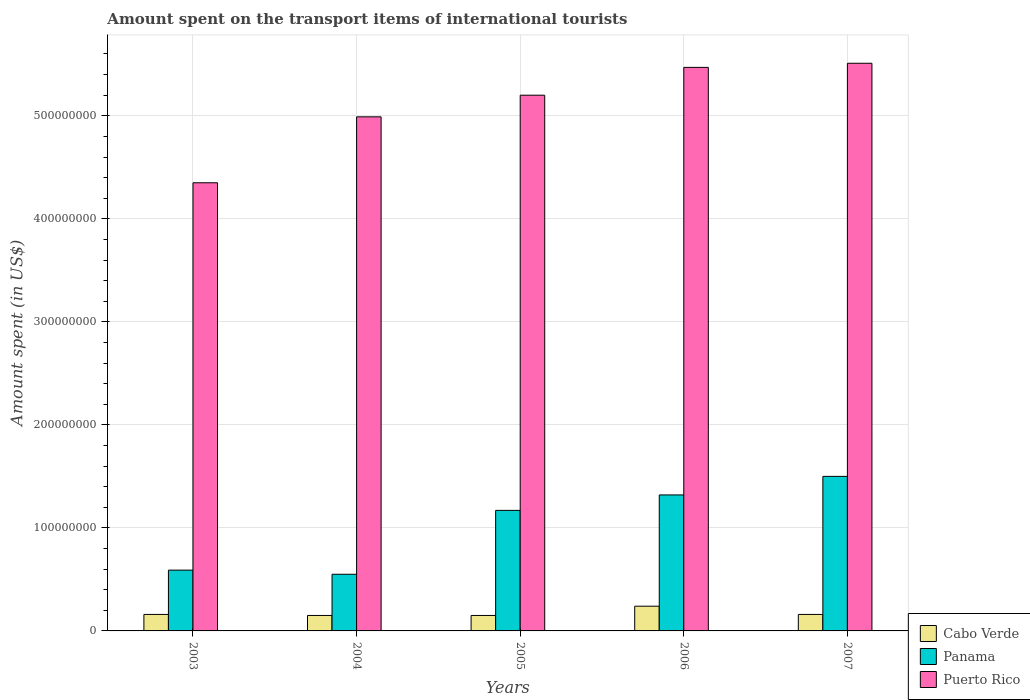How many groups of bars are there?
Give a very brief answer. 5. Are the number of bars on each tick of the X-axis equal?
Your answer should be very brief. Yes. What is the label of the 4th group of bars from the left?
Your answer should be compact. 2006. What is the amount spent on the transport items of international tourists in Panama in 2005?
Your answer should be compact. 1.17e+08. Across all years, what is the maximum amount spent on the transport items of international tourists in Panama?
Offer a terse response. 1.50e+08. Across all years, what is the minimum amount spent on the transport items of international tourists in Cabo Verde?
Offer a terse response. 1.50e+07. In which year was the amount spent on the transport items of international tourists in Cabo Verde maximum?
Make the answer very short. 2006. What is the total amount spent on the transport items of international tourists in Panama in the graph?
Offer a very short reply. 5.13e+08. What is the difference between the amount spent on the transport items of international tourists in Cabo Verde in 2005 and that in 2007?
Your response must be concise. -1.00e+06. What is the difference between the amount spent on the transport items of international tourists in Cabo Verde in 2006 and the amount spent on the transport items of international tourists in Puerto Rico in 2004?
Provide a short and direct response. -4.75e+08. What is the average amount spent on the transport items of international tourists in Puerto Rico per year?
Offer a terse response. 5.10e+08. In the year 2007, what is the difference between the amount spent on the transport items of international tourists in Cabo Verde and amount spent on the transport items of international tourists in Panama?
Your answer should be very brief. -1.34e+08. What is the ratio of the amount spent on the transport items of international tourists in Cabo Verde in 2003 to that in 2006?
Ensure brevity in your answer.  0.67. Is the amount spent on the transport items of international tourists in Panama in 2003 less than that in 2006?
Your response must be concise. Yes. Is the difference between the amount spent on the transport items of international tourists in Cabo Verde in 2005 and 2007 greater than the difference between the amount spent on the transport items of international tourists in Panama in 2005 and 2007?
Give a very brief answer. Yes. What is the difference between the highest and the second highest amount spent on the transport items of international tourists in Panama?
Keep it short and to the point. 1.80e+07. What is the difference between the highest and the lowest amount spent on the transport items of international tourists in Panama?
Provide a succinct answer. 9.50e+07. Is the sum of the amount spent on the transport items of international tourists in Cabo Verde in 2004 and 2005 greater than the maximum amount spent on the transport items of international tourists in Panama across all years?
Your answer should be compact. No. What does the 2nd bar from the left in 2004 represents?
Your answer should be compact. Panama. What does the 2nd bar from the right in 2006 represents?
Give a very brief answer. Panama. Is it the case that in every year, the sum of the amount spent on the transport items of international tourists in Puerto Rico and amount spent on the transport items of international tourists in Cabo Verde is greater than the amount spent on the transport items of international tourists in Panama?
Offer a terse response. Yes. How many years are there in the graph?
Offer a terse response. 5. What is the difference between two consecutive major ticks on the Y-axis?
Ensure brevity in your answer.  1.00e+08. Are the values on the major ticks of Y-axis written in scientific E-notation?
Your answer should be compact. No. Does the graph contain grids?
Ensure brevity in your answer.  Yes. How many legend labels are there?
Provide a short and direct response. 3. How are the legend labels stacked?
Your response must be concise. Vertical. What is the title of the graph?
Your answer should be compact. Amount spent on the transport items of international tourists. Does "Comoros" appear as one of the legend labels in the graph?
Provide a succinct answer. No. What is the label or title of the X-axis?
Offer a very short reply. Years. What is the label or title of the Y-axis?
Make the answer very short. Amount spent (in US$). What is the Amount spent (in US$) of Cabo Verde in 2003?
Give a very brief answer. 1.60e+07. What is the Amount spent (in US$) in Panama in 2003?
Your response must be concise. 5.90e+07. What is the Amount spent (in US$) of Puerto Rico in 2003?
Your answer should be compact. 4.35e+08. What is the Amount spent (in US$) of Cabo Verde in 2004?
Make the answer very short. 1.50e+07. What is the Amount spent (in US$) in Panama in 2004?
Your response must be concise. 5.50e+07. What is the Amount spent (in US$) of Puerto Rico in 2004?
Keep it short and to the point. 4.99e+08. What is the Amount spent (in US$) of Cabo Verde in 2005?
Your response must be concise. 1.50e+07. What is the Amount spent (in US$) in Panama in 2005?
Make the answer very short. 1.17e+08. What is the Amount spent (in US$) of Puerto Rico in 2005?
Your response must be concise. 5.20e+08. What is the Amount spent (in US$) in Cabo Verde in 2006?
Provide a short and direct response. 2.40e+07. What is the Amount spent (in US$) of Panama in 2006?
Your answer should be compact. 1.32e+08. What is the Amount spent (in US$) of Puerto Rico in 2006?
Ensure brevity in your answer.  5.47e+08. What is the Amount spent (in US$) of Cabo Verde in 2007?
Keep it short and to the point. 1.60e+07. What is the Amount spent (in US$) in Panama in 2007?
Your response must be concise. 1.50e+08. What is the Amount spent (in US$) in Puerto Rico in 2007?
Ensure brevity in your answer.  5.51e+08. Across all years, what is the maximum Amount spent (in US$) of Cabo Verde?
Your response must be concise. 2.40e+07. Across all years, what is the maximum Amount spent (in US$) in Panama?
Offer a very short reply. 1.50e+08. Across all years, what is the maximum Amount spent (in US$) in Puerto Rico?
Keep it short and to the point. 5.51e+08. Across all years, what is the minimum Amount spent (in US$) of Cabo Verde?
Provide a short and direct response. 1.50e+07. Across all years, what is the minimum Amount spent (in US$) of Panama?
Offer a very short reply. 5.50e+07. Across all years, what is the minimum Amount spent (in US$) in Puerto Rico?
Ensure brevity in your answer.  4.35e+08. What is the total Amount spent (in US$) in Cabo Verde in the graph?
Ensure brevity in your answer.  8.60e+07. What is the total Amount spent (in US$) of Panama in the graph?
Your answer should be compact. 5.13e+08. What is the total Amount spent (in US$) of Puerto Rico in the graph?
Provide a succinct answer. 2.55e+09. What is the difference between the Amount spent (in US$) of Cabo Verde in 2003 and that in 2004?
Provide a succinct answer. 1.00e+06. What is the difference between the Amount spent (in US$) in Panama in 2003 and that in 2004?
Your answer should be very brief. 4.00e+06. What is the difference between the Amount spent (in US$) in Puerto Rico in 2003 and that in 2004?
Provide a succinct answer. -6.40e+07. What is the difference between the Amount spent (in US$) in Panama in 2003 and that in 2005?
Provide a succinct answer. -5.80e+07. What is the difference between the Amount spent (in US$) in Puerto Rico in 2003 and that in 2005?
Offer a terse response. -8.50e+07. What is the difference between the Amount spent (in US$) in Cabo Verde in 2003 and that in 2006?
Your answer should be very brief. -8.00e+06. What is the difference between the Amount spent (in US$) in Panama in 2003 and that in 2006?
Give a very brief answer. -7.30e+07. What is the difference between the Amount spent (in US$) of Puerto Rico in 2003 and that in 2006?
Offer a terse response. -1.12e+08. What is the difference between the Amount spent (in US$) of Panama in 2003 and that in 2007?
Your answer should be compact. -9.10e+07. What is the difference between the Amount spent (in US$) of Puerto Rico in 2003 and that in 2007?
Your answer should be compact. -1.16e+08. What is the difference between the Amount spent (in US$) in Panama in 2004 and that in 2005?
Offer a terse response. -6.20e+07. What is the difference between the Amount spent (in US$) in Puerto Rico in 2004 and that in 2005?
Your answer should be compact. -2.10e+07. What is the difference between the Amount spent (in US$) in Cabo Verde in 2004 and that in 2006?
Provide a succinct answer. -9.00e+06. What is the difference between the Amount spent (in US$) in Panama in 2004 and that in 2006?
Your answer should be very brief. -7.70e+07. What is the difference between the Amount spent (in US$) in Puerto Rico in 2004 and that in 2006?
Give a very brief answer. -4.80e+07. What is the difference between the Amount spent (in US$) in Cabo Verde in 2004 and that in 2007?
Offer a very short reply. -1.00e+06. What is the difference between the Amount spent (in US$) in Panama in 2004 and that in 2007?
Your answer should be compact. -9.50e+07. What is the difference between the Amount spent (in US$) of Puerto Rico in 2004 and that in 2007?
Provide a short and direct response. -5.20e+07. What is the difference between the Amount spent (in US$) of Cabo Verde in 2005 and that in 2006?
Keep it short and to the point. -9.00e+06. What is the difference between the Amount spent (in US$) of Panama in 2005 and that in 2006?
Keep it short and to the point. -1.50e+07. What is the difference between the Amount spent (in US$) of Puerto Rico in 2005 and that in 2006?
Your response must be concise. -2.70e+07. What is the difference between the Amount spent (in US$) in Panama in 2005 and that in 2007?
Your response must be concise. -3.30e+07. What is the difference between the Amount spent (in US$) in Puerto Rico in 2005 and that in 2007?
Provide a short and direct response. -3.10e+07. What is the difference between the Amount spent (in US$) in Panama in 2006 and that in 2007?
Your answer should be very brief. -1.80e+07. What is the difference between the Amount spent (in US$) in Puerto Rico in 2006 and that in 2007?
Give a very brief answer. -4.00e+06. What is the difference between the Amount spent (in US$) of Cabo Verde in 2003 and the Amount spent (in US$) of Panama in 2004?
Keep it short and to the point. -3.90e+07. What is the difference between the Amount spent (in US$) in Cabo Verde in 2003 and the Amount spent (in US$) in Puerto Rico in 2004?
Offer a terse response. -4.83e+08. What is the difference between the Amount spent (in US$) in Panama in 2003 and the Amount spent (in US$) in Puerto Rico in 2004?
Offer a terse response. -4.40e+08. What is the difference between the Amount spent (in US$) in Cabo Verde in 2003 and the Amount spent (in US$) in Panama in 2005?
Give a very brief answer. -1.01e+08. What is the difference between the Amount spent (in US$) of Cabo Verde in 2003 and the Amount spent (in US$) of Puerto Rico in 2005?
Offer a terse response. -5.04e+08. What is the difference between the Amount spent (in US$) in Panama in 2003 and the Amount spent (in US$) in Puerto Rico in 2005?
Offer a very short reply. -4.61e+08. What is the difference between the Amount spent (in US$) in Cabo Verde in 2003 and the Amount spent (in US$) in Panama in 2006?
Provide a succinct answer. -1.16e+08. What is the difference between the Amount spent (in US$) in Cabo Verde in 2003 and the Amount spent (in US$) in Puerto Rico in 2006?
Give a very brief answer. -5.31e+08. What is the difference between the Amount spent (in US$) of Panama in 2003 and the Amount spent (in US$) of Puerto Rico in 2006?
Provide a succinct answer. -4.88e+08. What is the difference between the Amount spent (in US$) of Cabo Verde in 2003 and the Amount spent (in US$) of Panama in 2007?
Give a very brief answer. -1.34e+08. What is the difference between the Amount spent (in US$) of Cabo Verde in 2003 and the Amount spent (in US$) of Puerto Rico in 2007?
Your answer should be compact. -5.35e+08. What is the difference between the Amount spent (in US$) in Panama in 2003 and the Amount spent (in US$) in Puerto Rico in 2007?
Make the answer very short. -4.92e+08. What is the difference between the Amount spent (in US$) in Cabo Verde in 2004 and the Amount spent (in US$) in Panama in 2005?
Ensure brevity in your answer.  -1.02e+08. What is the difference between the Amount spent (in US$) in Cabo Verde in 2004 and the Amount spent (in US$) in Puerto Rico in 2005?
Keep it short and to the point. -5.05e+08. What is the difference between the Amount spent (in US$) in Panama in 2004 and the Amount spent (in US$) in Puerto Rico in 2005?
Your answer should be compact. -4.65e+08. What is the difference between the Amount spent (in US$) in Cabo Verde in 2004 and the Amount spent (in US$) in Panama in 2006?
Your response must be concise. -1.17e+08. What is the difference between the Amount spent (in US$) in Cabo Verde in 2004 and the Amount spent (in US$) in Puerto Rico in 2006?
Make the answer very short. -5.32e+08. What is the difference between the Amount spent (in US$) of Panama in 2004 and the Amount spent (in US$) of Puerto Rico in 2006?
Your answer should be compact. -4.92e+08. What is the difference between the Amount spent (in US$) in Cabo Verde in 2004 and the Amount spent (in US$) in Panama in 2007?
Offer a very short reply. -1.35e+08. What is the difference between the Amount spent (in US$) of Cabo Verde in 2004 and the Amount spent (in US$) of Puerto Rico in 2007?
Offer a very short reply. -5.36e+08. What is the difference between the Amount spent (in US$) of Panama in 2004 and the Amount spent (in US$) of Puerto Rico in 2007?
Provide a succinct answer. -4.96e+08. What is the difference between the Amount spent (in US$) in Cabo Verde in 2005 and the Amount spent (in US$) in Panama in 2006?
Give a very brief answer. -1.17e+08. What is the difference between the Amount spent (in US$) in Cabo Verde in 2005 and the Amount spent (in US$) in Puerto Rico in 2006?
Keep it short and to the point. -5.32e+08. What is the difference between the Amount spent (in US$) in Panama in 2005 and the Amount spent (in US$) in Puerto Rico in 2006?
Provide a succinct answer. -4.30e+08. What is the difference between the Amount spent (in US$) in Cabo Verde in 2005 and the Amount spent (in US$) in Panama in 2007?
Keep it short and to the point. -1.35e+08. What is the difference between the Amount spent (in US$) in Cabo Verde in 2005 and the Amount spent (in US$) in Puerto Rico in 2007?
Offer a very short reply. -5.36e+08. What is the difference between the Amount spent (in US$) of Panama in 2005 and the Amount spent (in US$) of Puerto Rico in 2007?
Ensure brevity in your answer.  -4.34e+08. What is the difference between the Amount spent (in US$) in Cabo Verde in 2006 and the Amount spent (in US$) in Panama in 2007?
Provide a short and direct response. -1.26e+08. What is the difference between the Amount spent (in US$) in Cabo Verde in 2006 and the Amount spent (in US$) in Puerto Rico in 2007?
Your answer should be very brief. -5.27e+08. What is the difference between the Amount spent (in US$) of Panama in 2006 and the Amount spent (in US$) of Puerto Rico in 2007?
Your answer should be compact. -4.19e+08. What is the average Amount spent (in US$) of Cabo Verde per year?
Ensure brevity in your answer.  1.72e+07. What is the average Amount spent (in US$) in Panama per year?
Ensure brevity in your answer.  1.03e+08. What is the average Amount spent (in US$) in Puerto Rico per year?
Make the answer very short. 5.10e+08. In the year 2003, what is the difference between the Amount spent (in US$) of Cabo Verde and Amount spent (in US$) of Panama?
Keep it short and to the point. -4.30e+07. In the year 2003, what is the difference between the Amount spent (in US$) of Cabo Verde and Amount spent (in US$) of Puerto Rico?
Your response must be concise. -4.19e+08. In the year 2003, what is the difference between the Amount spent (in US$) in Panama and Amount spent (in US$) in Puerto Rico?
Offer a very short reply. -3.76e+08. In the year 2004, what is the difference between the Amount spent (in US$) of Cabo Verde and Amount spent (in US$) of Panama?
Your answer should be compact. -4.00e+07. In the year 2004, what is the difference between the Amount spent (in US$) of Cabo Verde and Amount spent (in US$) of Puerto Rico?
Give a very brief answer. -4.84e+08. In the year 2004, what is the difference between the Amount spent (in US$) of Panama and Amount spent (in US$) of Puerto Rico?
Provide a succinct answer. -4.44e+08. In the year 2005, what is the difference between the Amount spent (in US$) of Cabo Verde and Amount spent (in US$) of Panama?
Your response must be concise. -1.02e+08. In the year 2005, what is the difference between the Amount spent (in US$) of Cabo Verde and Amount spent (in US$) of Puerto Rico?
Keep it short and to the point. -5.05e+08. In the year 2005, what is the difference between the Amount spent (in US$) in Panama and Amount spent (in US$) in Puerto Rico?
Your response must be concise. -4.03e+08. In the year 2006, what is the difference between the Amount spent (in US$) of Cabo Verde and Amount spent (in US$) of Panama?
Your answer should be compact. -1.08e+08. In the year 2006, what is the difference between the Amount spent (in US$) in Cabo Verde and Amount spent (in US$) in Puerto Rico?
Your answer should be compact. -5.23e+08. In the year 2006, what is the difference between the Amount spent (in US$) of Panama and Amount spent (in US$) of Puerto Rico?
Provide a short and direct response. -4.15e+08. In the year 2007, what is the difference between the Amount spent (in US$) of Cabo Verde and Amount spent (in US$) of Panama?
Your answer should be very brief. -1.34e+08. In the year 2007, what is the difference between the Amount spent (in US$) of Cabo Verde and Amount spent (in US$) of Puerto Rico?
Provide a succinct answer. -5.35e+08. In the year 2007, what is the difference between the Amount spent (in US$) in Panama and Amount spent (in US$) in Puerto Rico?
Your answer should be compact. -4.01e+08. What is the ratio of the Amount spent (in US$) in Cabo Verde in 2003 to that in 2004?
Offer a terse response. 1.07. What is the ratio of the Amount spent (in US$) in Panama in 2003 to that in 2004?
Offer a very short reply. 1.07. What is the ratio of the Amount spent (in US$) of Puerto Rico in 2003 to that in 2004?
Provide a succinct answer. 0.87. What is the ratio of the Amount spent (in US$) in Cabo Verde in 2003 to that in 2005?
Your answer should be compact. 1.07. What is the ratio of the Amount spent (in US$) in Panama in 2003 to that in 2005?
Provide a short and direct response. 0.5. What is the ratio of the Amount spent (in US$) of Puerto Rico in 2003 to that in 2005?
Keep it short and to the point. 0.84. What is the ratio of the Amount spent (in US$) of Cabo Verde in 2003 to that in 2006?
Your answer should be compact. 0.67. What is the ratio of the Amount spent (in US$) in Panama in 2003 to that in 2006?
Offer a very short reply. 0.45. What is the ratio of the Amount spent (in US$) of Puerto Rico in 2003 to that in 2006?
Your answer should be very brief. 0.8. What is the ratio of the Amount spent (in US$) of Panama in 2003 to that in 2007?
Offer a terse response. 0.39. What is the ratio of the Amount spent (in US$) of Puerto Rico in 2003 to that in 2007?
Your answer should be compact. 0.79. What is the ratio of the Amount spent (in US$) in Cabo Verde in 2004 to that in 2005?
Your response must be concise. 1. What is the ratio of the Amount spent (in US$) of Panama in 2004 to that in 2005?
Make the answer very short. 0.47. What is the ratio of the Amount spent (in US$) of Puerto Rico in 2004 to that in 2005?
Offer a terse response. 0.96. What is the ratio of the Amount spent (in US$) in Cabo Verde in 2004 to that in 2006?
Provide a short and direct response. 0.62. What is the ratio of the Amount spent (in US$) in Panama in 2004 to that in 2006?
Give a very brief answer. 0.42. What is the ratio of the Amount spent (in US$) of Puerto Rico in 2004 to that in 2006?
Your response must be concise. 0.91. What is the ratio of the Amount spent (in US$) of Panama in 2004 to that in 2007?
Provide a succinct answer. 0.37. What is the ratio of the Amount spent (in US$) of Puerto Rico in 2004 to that in 2007?
Provide a short and direct response. 0.91. What is the ratio of the Amount spent (in US$) in Panama in 2005 to that in 2006?
Offer a very short reply. 0.89. What is the ratio of the Amount spent (in US$) of Puerto Rico in 2005 to that in 2006?
Your response must be concise. 0.95. What is the ratio of the Amount spent (in US$) of Panama in 2005 to that in 2007?
Offer a very short reply. 0.78. What is the ratio of the Amount spent (in US$) of Puerto Rico in 2005 to that in 2007?
Ensure brevity in your answer.  0.94. What is the ratio of the Amount spent (in US$) of Cabo Verde in 2006 to that in 2007?
Provide a short and direct response. 1.5. What is the difference between the highest and the second highest Amount spent (in US$) of Panama?
Offer a very short reply. 1.80e+07. What is the difference between the highest and the second highest Amount spent (in US$) in Puerto Rico?
Make the answer very short. 4.00e+06. What is the difference between the highest and the lowest Amount spent (in US$) of Cabo Verde?
Offer a very short reply. 9.00e+06. What is the difference between the highest and the lowest Amount spent (in US$) of Panama?
Ensure brevity in your answer.  9.50e+07. What is the difference between the highest and the lowest Amount spent (in US$) of Puerto Rico?
Ensure brevity in your answer.  1.16e+08. 